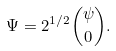Convert formula to latex. <formula><loc_0><loc_0><loc_500><loc_500>\Psi = 2 ^ { 1 / 2 } { \psi \choose 0 } .</formula> 